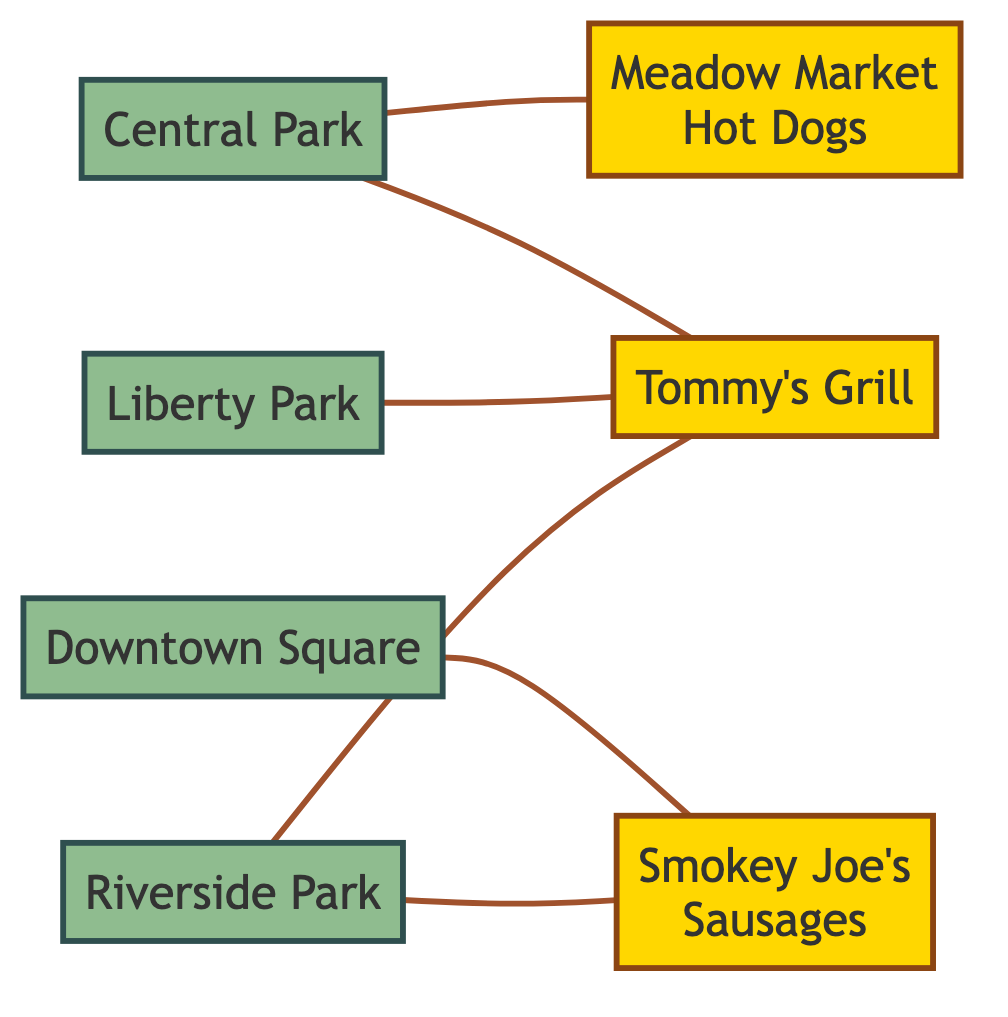What's the total number of parks in the diagram? The diagram lists four parks: Central Park, Liberty Park, Downtown Square, and Riverside Park. By counting the nodes labeled as parks, we determine that there are four in total.
Answer: 4 How many hot dog vendors are connected to Riverside Park? Riverside Park is connected to two vendors: Tommy's Grill and Smokey Joe's Sausages. By examining the edges from Riverside Park, we can count these two connections.
Answer: 2 Which vendor is linked to both Central Park and Riverside Park? Tommy's Grill is the only vendor directly connected to both Central Park and Riverside Park. We check the edges from each park and find this vendor common to both.
Answer: Tommy's Grill What is the only park connected to Smokey Joe's Sausages? The only park connected to Smokey Joe's Sausages is Downtown Square. This can be confirmed by looking at the edges and noting that Downtown Square is the sole park linked to this vendor.
Answer: Downtown Square Are there any parks with no hot dog vendors connected to them? Yes, Liberty Park has no hot dog vendors connected to it, as it has only one edge leading to Tommy's Grill without any connections to a vendor. This can be verified by reviewing the edges linked to each park.
Answer: Yes Which park has the most links to hot dog vendors? Riverside Park has two links to hot dog vendors: Tommy's Grill and Smokey Joe's Sausages. By comparing the number of edges connected to each park, Riverside Park has the highest count, more than any other park.
Answer: Riverside Park What type of graph is represented in the diagram? The diagram represents an undirected graph, as the connections (edges) between parks and vendors do not have a specified direction. This characteristic defines it as undirected.
Answer: Undirected Graph How many edges are there in total? The total number of edges in the graph is six. By counting each connection from the park nodes to the vendor nodes, we find that there are six distinct links.
Answer: 6 